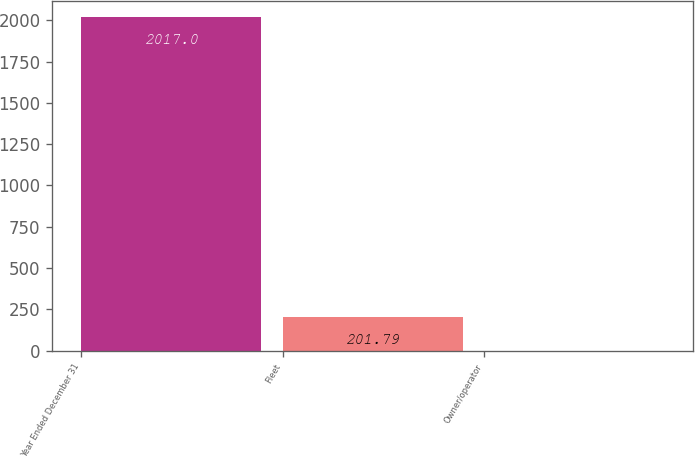Convert chart. <chart><loc_0><loc_0><loc_500><loc_500><bar_chart><fcel>Year Ended December 31<fcel>Fleet<fcel>Owner/operator<nl><fcel>2017<fcel>201.79<fcel>0.1<nl></chart> 